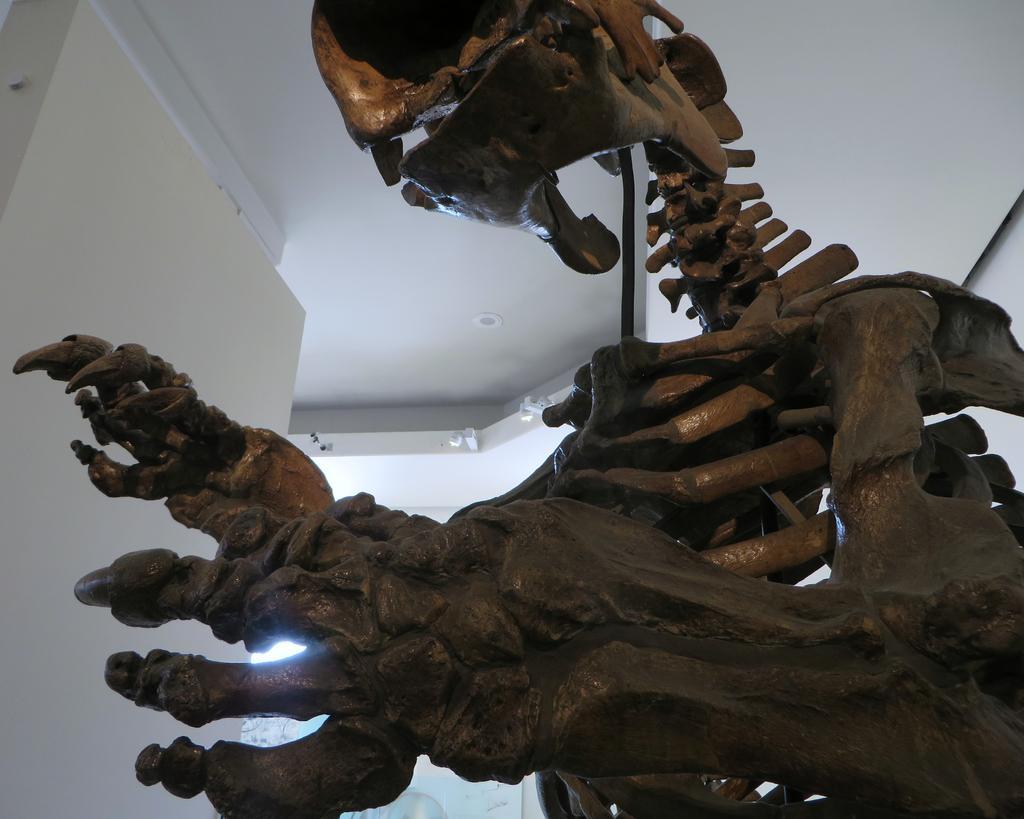Can you describe this image briefly? This is a skeleton of dinosaur, this is wall. 